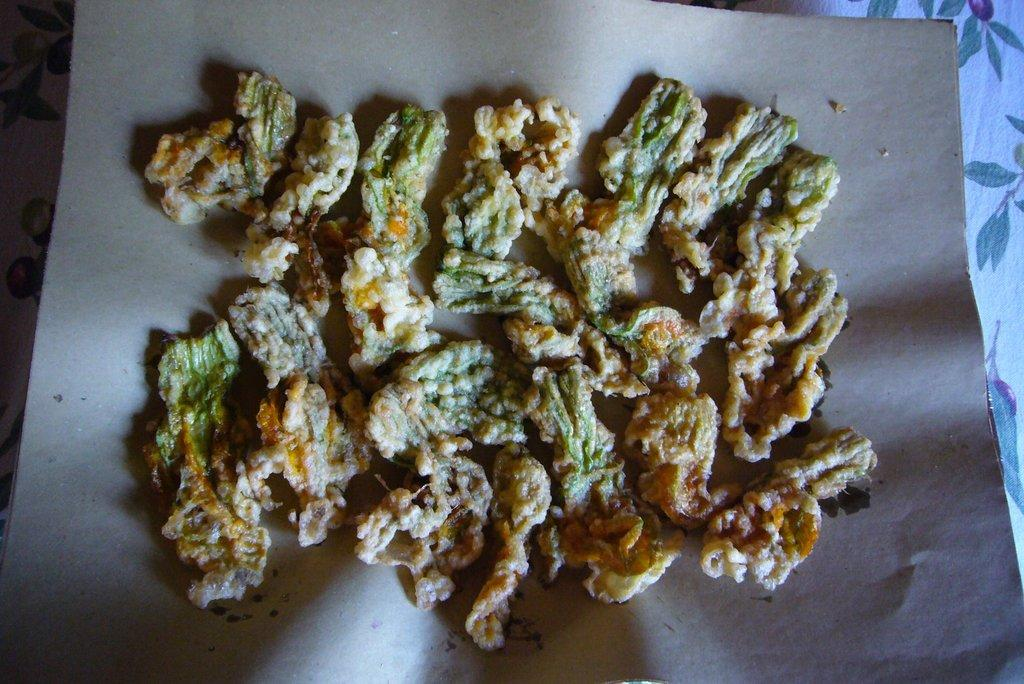What is present in the image that can be eaten? There are food items in the image. How are the food items arranged in the image? The food items are placed on a paper. What is the paper resting on in the image? The paper is placed on a cloth. What type of cheese can be seen on the prisoner's lip in the image? There is no prisoner or cheese present in the image. 